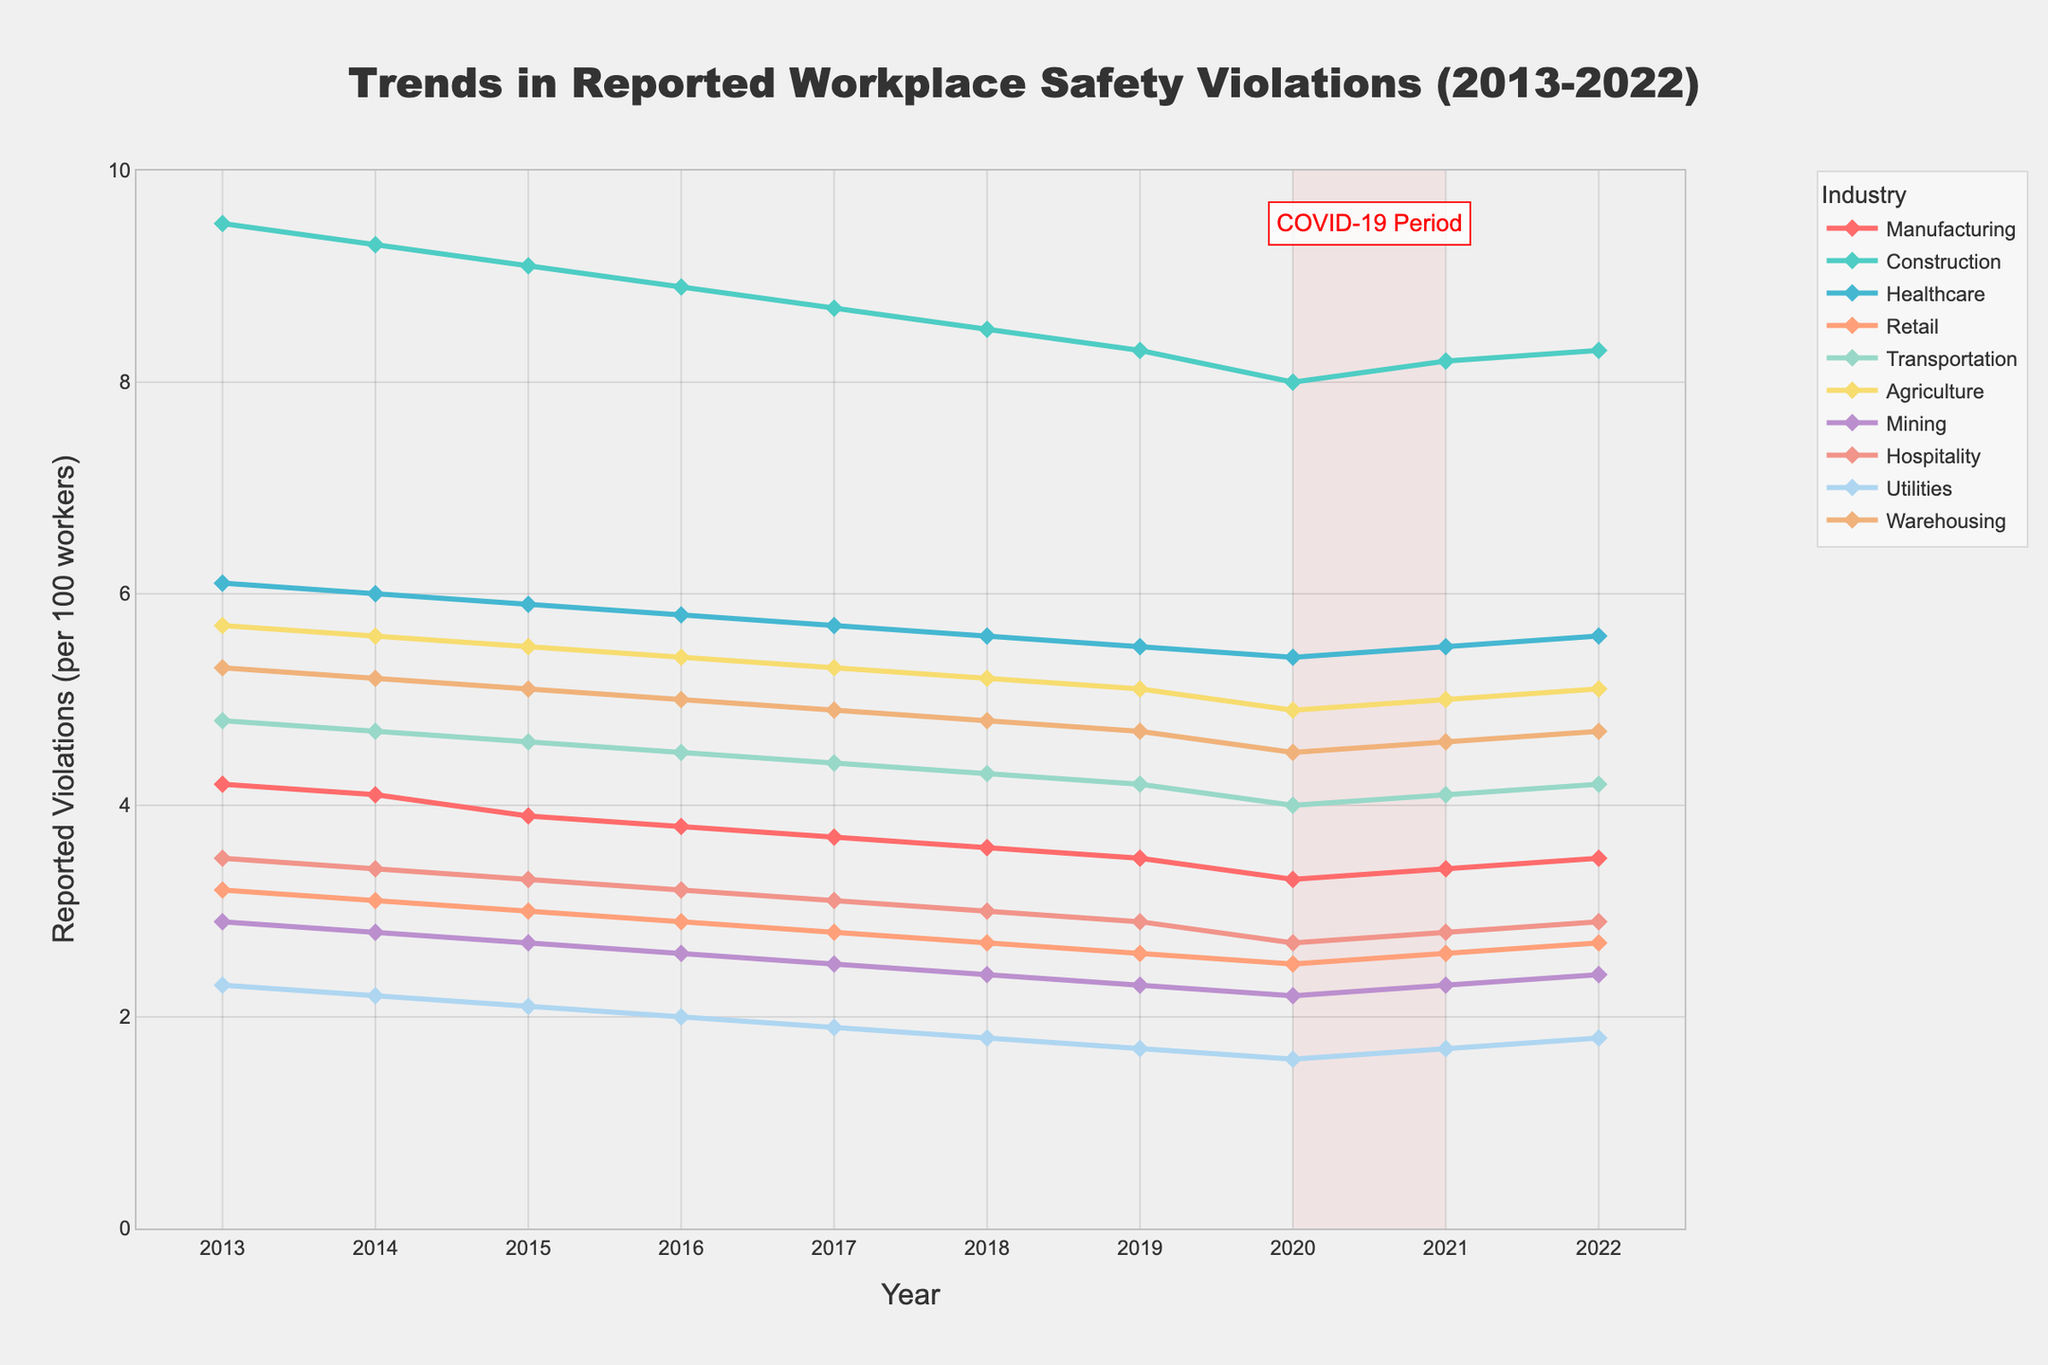what industry had the highest reported workplace safety violations in 2022? Look at the 2022 data points and identify the highest value. The highest is 8.3 for the Construction industry.
Answer: Construction how did the reported violations in Manufacturing change from 2019 to 2020 to 2021? Look at the values for Manufacturing from 2019 to 2021: 3.5 in 2019, 3.3 in 2020, and 3.4 in 2021. It decreased from 3.5 to 3.3, then increased to 3.4.
Answer: Decreased, then increased which industry showed the most consistent decrease in reported violations from 2013 to 2022? Scan the lines for each industry from 2013 to 2022. Construction shows a consistent decreasing trend from 9.5 to 8.3.
Answer: Construction During the COVID-19 period (2020-2021), which industries showed an increase in reported violations? Focus on the period from 2020 to 2021. Manufacturing, Construction, Healthcare, Retail, Transportation, Agriculture, Mining, Hospitality, Utilities, and Warehousing are the industries. Look for those which increased: Manufacturing (3.3 to 3.4), Construction (8.0 to 8.2), Healthcare (5.4 to 5.5), Retail (2.5 to 2.6), Transportation (4.0 to 4.1), Agriculture (4.9 to 5.0), Mining (2.2 to 2.3), Hospitality (2.7 to 2.8), Utilities (1.6 to 1.7), Warehousing (4.5 to 4.6)
Answer: All industries which industry had the lowest reported workplace safety violations in 2013? Look at the 2013 data points and find the lowest value. The lowest is 2.3 for Utilities.
Answer: Utilities how many industries had reported violations below 4.0 in 2022? Identify the values below 4.0 in 2022: Manufacturing (3.5), Retail (2.7), Mining (2.4), Utilities (1.8), and Hospitality (2.9). Count them.
Answer: 5 compare the trends in reported violations between Healthcare and Warehousing from 2013 to 2022. Look at the lines for Healthcare and Warehousing between 2013 and 2022. Both show a general decreasing trend. Healthcare starts at 6.1 and ends at 5.6, Warehousing starts at 5.3 and ends at 4.7. Healthcare's trend is smoother.
Answer: Both decreased across all industries, which year had the highest average reported violations? Calculate the average of all industries for each year and find the highest. This requires steps:
2013: (4.2+9.5+6.1+3.2+4.8+5.7+2.9+3.5+2.3+5.3)/10 = 4.75
2014: (4.1+9.3+6.0+3.1+4.7+5.6+2.8+3.4+2.2+5.2)/10 = 4.64
2015: (3.9+9.1+5.9+3.0+4.6+5.5+2.7+3.3+2.1+5.1)/10 = 4.52
2016: (3.8+8.9+5.8+2.9+4.5+5.4+2.6+3.2+2.0+5.0)/10 = 4.41
2017: (3.7+8.7+5.7+2.8+4.4+5.3+2.5+3.1+1.9+4.9)/10 = 4.3
2018: (3.6+8.5+5.6+2.7+4.3+5.2+2.4+3.0+1.8+4.8)/10 = 4.19
2019: (3.5+8.3+5.5+2.6+4.2+5.1+2.3+2.9+1.7+4.7)/10 = 4.08
2020: (3.3+8.0+5.4+2.5+4.0+4.9+2.2+2.7+1.6+4.5)/10 = 3.91
2021: (3.4+8.2+5.5+2.6+4.1+5.0+2.3+2.8+1.7+4.6)/10 = 4.02
2022: (3.5+8.3+5.6+2.7+4.2+5.1+2.4+2.9+1.8+4.7)/10 = 4.12 2013 has the highest average of 4.75.
Answer: 2013 